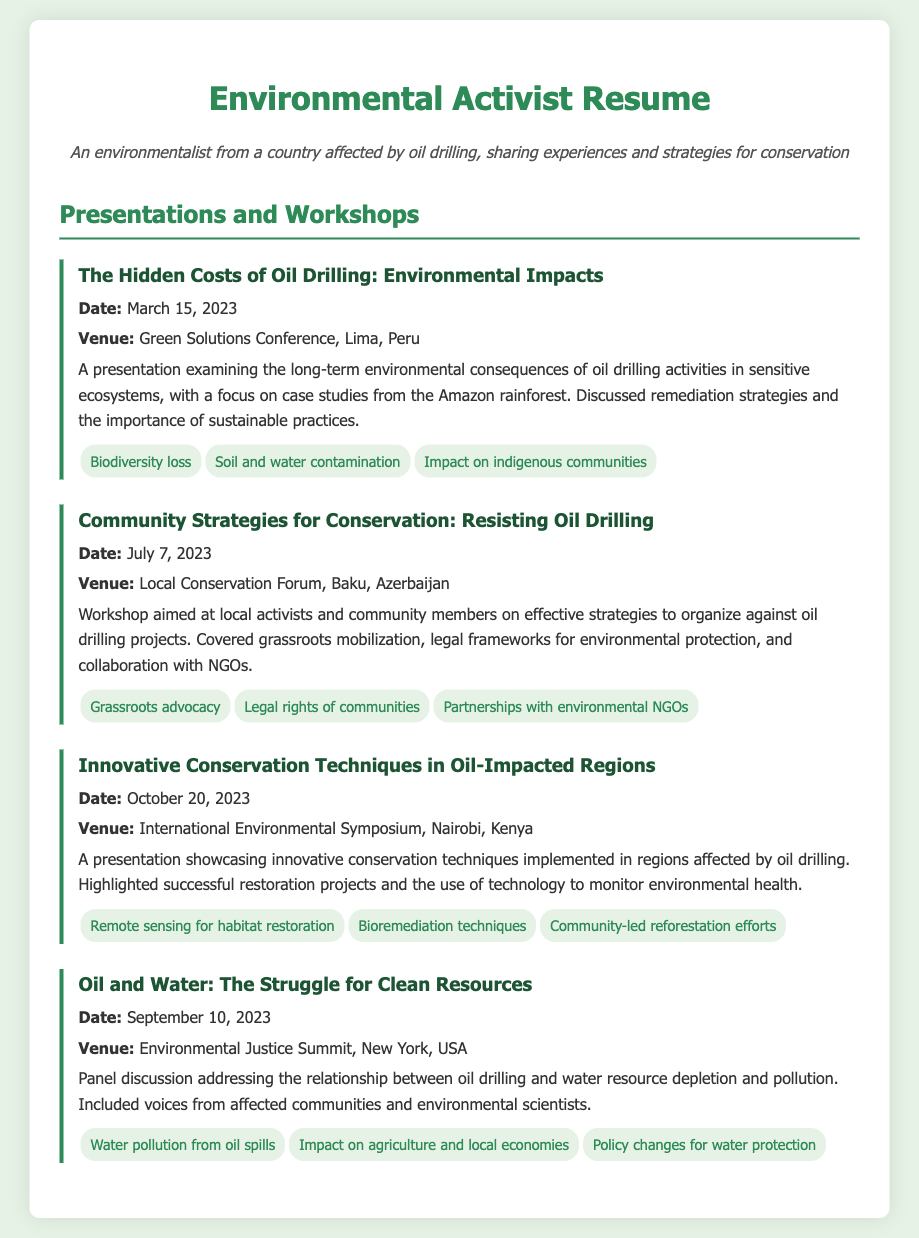what is the title of the first presentation? The title of the first presentation is listed in the document under the presentations section.
Answer: The Hidden Costs of Oil Drilling: Environmental Impacts when was the workshop on Community Strategies for Conservation held? The date is specified in the workshop details within the document.
Answer: July 7, 2023 where was the International Environmental Symposium held? The venue is mentioned in the details of the third presentation.
Answer: Nairobi, Kenya what was a key topic discussed in the panel discussion on oil and water? Key topics are listed under each presentation in the document.
Answer: Water pollution from oil spills how many presentations are listed in the document? The total number of presentations can be counted from the document's section.
Answer: Four what is the main focus of the workshop on Community Strategies for Conservation? The main focus is described in the workshop overview provided in the document.
Answer: Effective strategies to organize against oil drilling projects which presentation discusses remediation strategies? This detail can be found in the description of one of the presentations.
Answer: The Hidden Costs of Oil Drilling: Environmental Impacts what significant technique is highlighted in the presentation on Innovative Conservation Techniques? The document mentions key topics for each presentation highlighting significant techniques.
Answer: Remote sensing for habitat restoration who was a panelist at the Environmental Justice Summit? The document indicates the nature of the discussion but not specific names, focusing on the type of contributors.
Answer: Affected communities and environmental scientists 